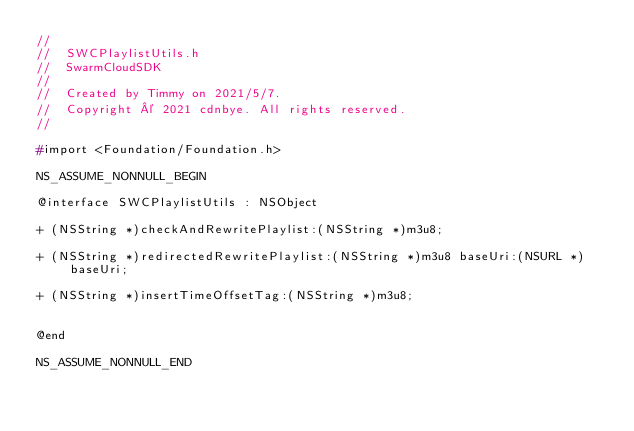Convert code to text. <code><loc_0><loc_0><loc_500><loc_500><_C_>//
//  SWCPlaylistUtils.h
//  SwarmCloudSDK
//
//  Created by Timmy on 2021/5/7.
//  Copyright © 2021 cdnbye. All rights reserved.
//

#import <Foundation/Foundation.h>

NS_ASSUME_NONNULL_BEGIN

@interface SWCPlaylistUtils : NSObject

+ (NSString *)checkAndRewritePlaylist:(NSString *)m3u8;

+ (NSString *)redirectedRewritePlaylist:(NSString *)m3u8 baseUri:(NSURL *)baseUri;

+ (NSString *)insertTimeOffsetTag:(NSString *)m3u8;


@end

NS_ASSUME_NONNULL_END
</code> 